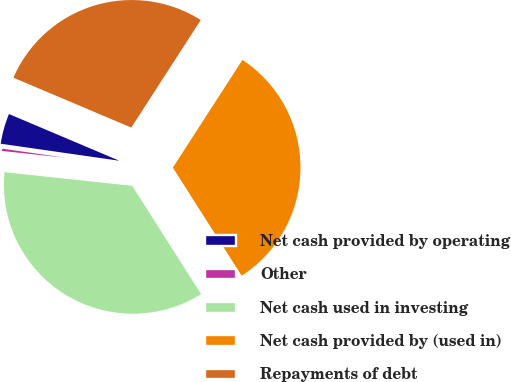Convert chart. <chart><loc_0><loc_0><loc_500><loc_500><pie_chart><fcel>Net cash provided by operating<fcel>Other<fcel>Net cash used in investing<fcel>Net cash provided by (used in)<fcel>Repayments of debt<nl><fcel>4.1%<fcel>0.58%<fcel>35.71%<fcel>31.85%<fcel>27.76%<nl></chart> 